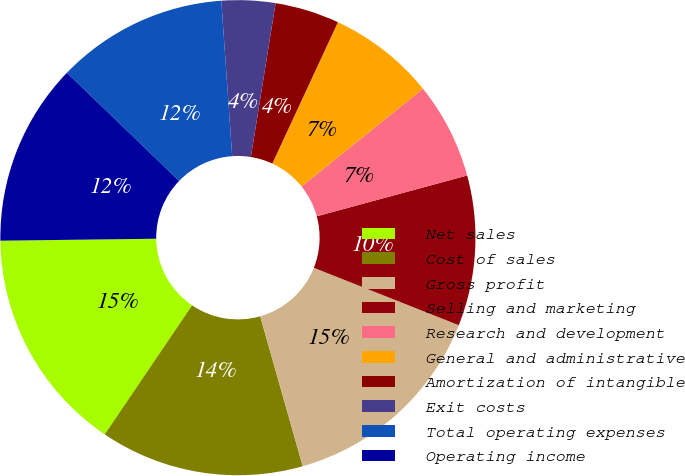Convert chart to OTSL. <chart><loc_0><loc_0><loc_500><loc_500><pie_chart><fcel>Net sales<fcel>Cost of sales<fcel>Gross profit<fcel>Selling and marketing<fcel>Research and development<fcel>General and administrative<fcel>Amortization of intangible<fcel>Exit costs<fcel>Total operating expenses<fcel>Operating income<nl><fcel>15.33%<fcel>13.87%<fcel>14.6%<fcel>10.22%<fcel>6.57%<fcel>7.3%<fcel>4.38%<fcel>3.65%<fcel>11.68%<fcel>12.41%<nl></chart> 